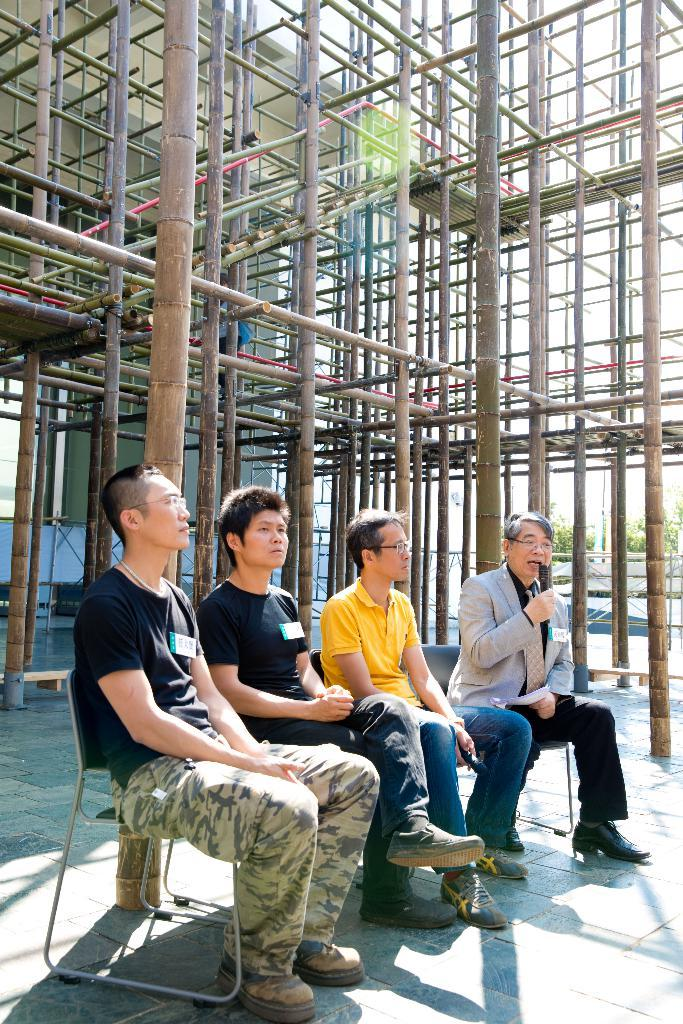How many people are sitting in the image? There are four persons sitting on chairs in the image. What can be seen in the background of the image? In the background, there are bamboo sticks, a building, trees, and the sky. Can you describe the setting of the image? The image shows four people sitting on chairs, with a natural background that includes bamboo sticks, a building, trees, and the sky. How many pins are holding the chairs together in the image? There are no pins visible in the image; the chairs are not held together by pins. 